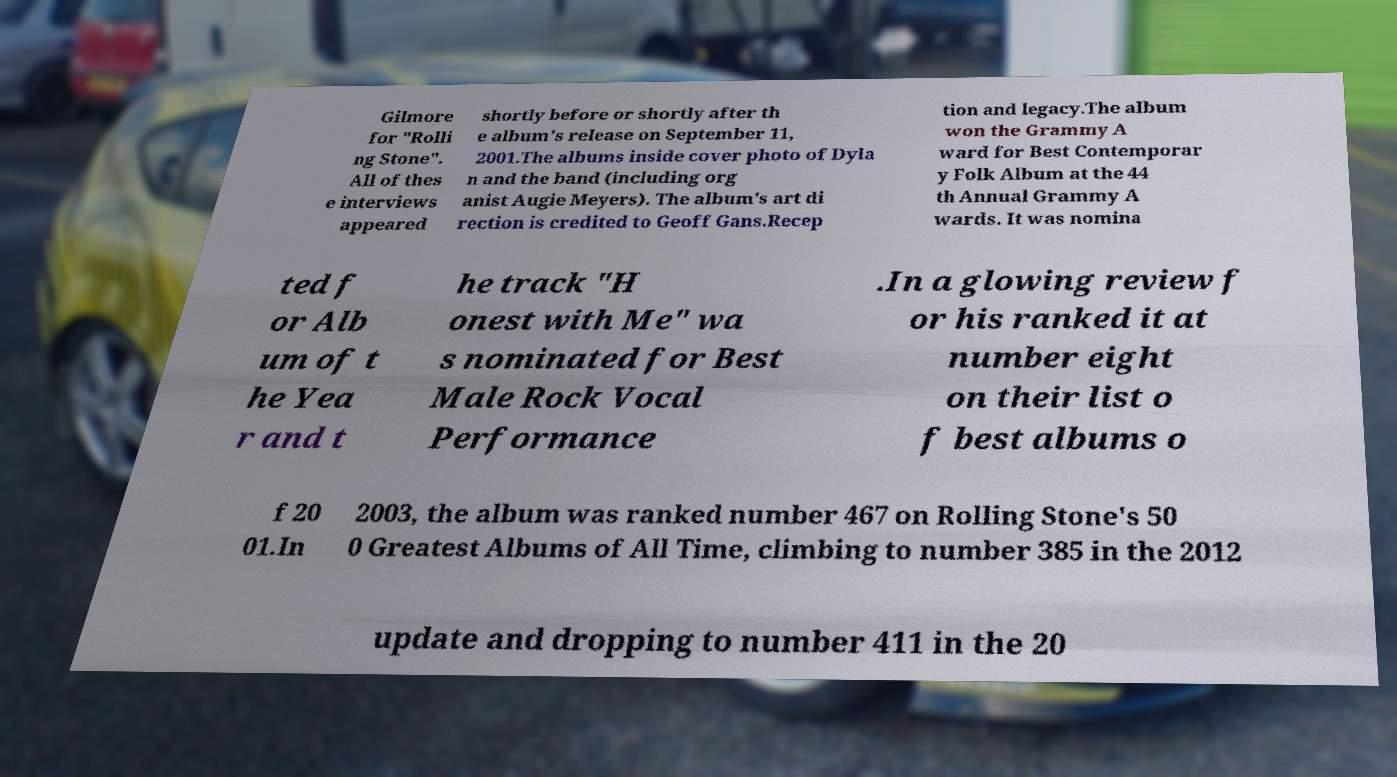Could you assist in decoding the text presented in this image and type it out clearly? Gilmore for "Rolli ng Stone". All of thes e interviews appeared shortly before or shortly after th e album's release on September 11, 2001.The albums inside cover photo of Dyla n and the band (including org anist Augie Meyers). The album's art di rection is credited to Geoff Gans.Recep tion and legacy.The album won the Grammy A ward for Best Contemporar y Folk Album at the 44 th Annual Grammy A wards. It was nomina ted f or Alb um of t he Yea r and t he track "H onest with Me" wa s nominated for Best Male Rock Vocal Performance .In a glowing review f or his ranked it at number eight on their list o f best albums o f 20 01.In 2003, the album was ranked number 467 on Rolling Stone's 50 0 Greatest Albums of All Time, climbing to number 385 in the 2012 update and dropping to number 411 in the 20 